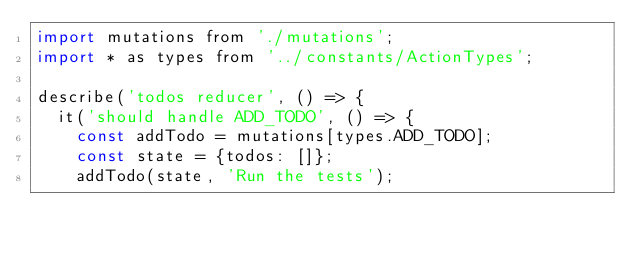<code> <loc_0><loc_0><loc_500><loc_500><_JavaScript_>import mutations from './mutations';
import * as types from '../constants/ActionTypes';

describe('todos reducer', () => {
  it('should handle ADD_TODO', () => {
    const addTodo = mutations[types.ADD_TODO];
    const state = {todos: []};
    addTodo(state, 'Run the tests');</code> 